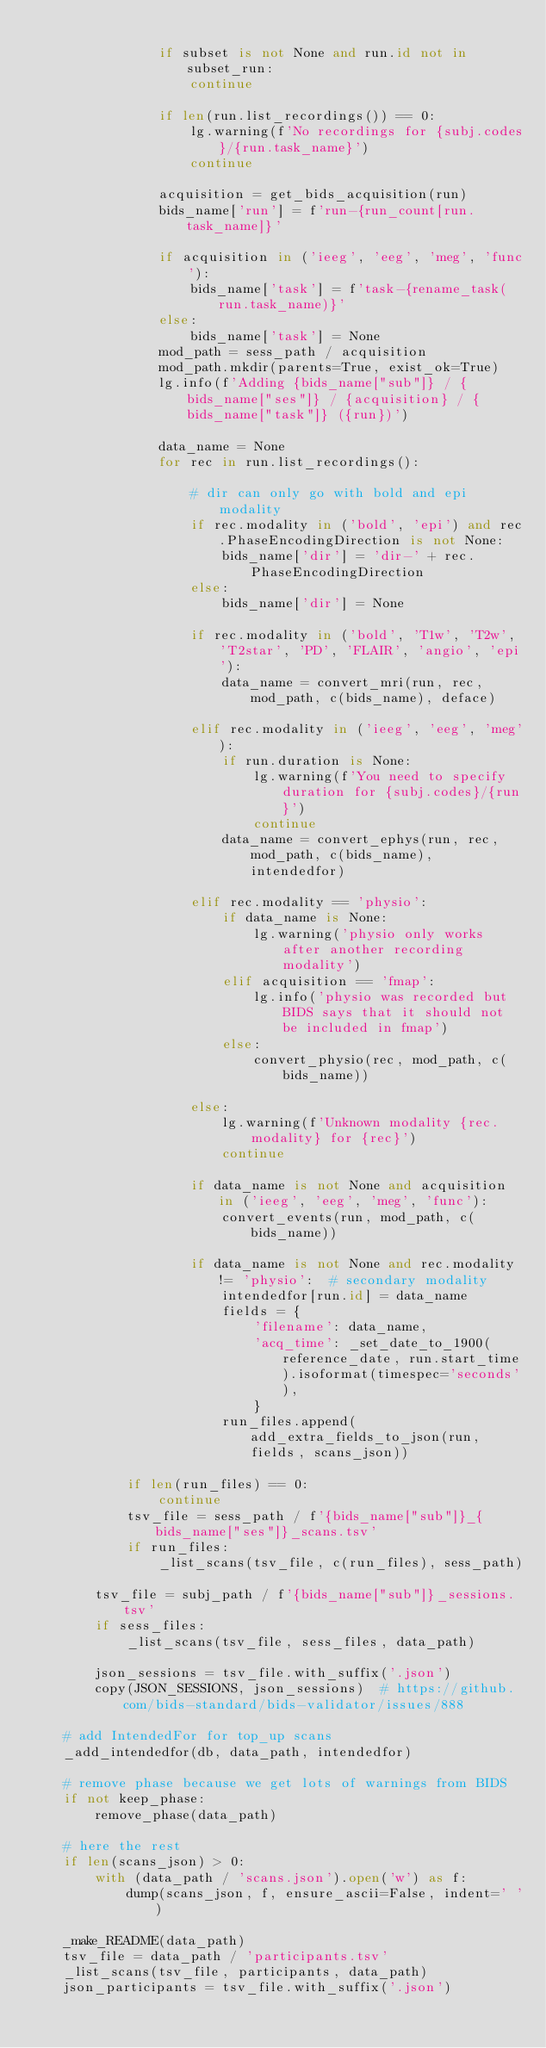Convert code to text. <code><loc_0><loc_0><loc_500><loc_500><_Python_>
                if subset is not None and run.id not in subset_run:
                    continue

                if len(run.list_recordings()) == 0:
                    lg.warning(f'No recordings for {subj.codes}/{run.task_name}')
                    continue

                acquisition = get_bids_acquisition(run)
                bids_name['run'] = f'run-{run_count[run.task_name]}'

                if acquisition in ('ieeg', 'eeg', 'meg', 'func'):
                    bids_name['task'] = f'task-{rename_task(run.task_name)}'
                else:
                    bids_name['task'] = None
                mod_path = sess_path / acquisition
                mod_path.mkdir(parents=True, exist_ok=True)
                lg.info(f'Adding {bids_name["sub"]} / {bids_name["ses"]} / {acquisition} / {bids_name["task"]} ({run})')

                data_name = None
                for rec in run.list_recordings():

                    # dir can only go with bold and epi modality
                    if rec.modality in ('bold', 'epi') and rec.PhaseEncodingDirection is not None:
                        bids_name['dir'] = 'dir-' + rec.PhaseEncodingDirection
                    else:
                        bids_name['dir'] = None

                    if rec.modality in ('bold', 'T1w', 'T2w', 'T2star', 'PD', 'FLAIR', 'angio', 'epi'):
                        data_name = convert_mri(run, rec, mod_path, c(bids_name), deface)

                    elif rec.modality in ('ieeg', 'eeg', 'meg'):
                        if run.duration is None:
                            lg.warning(f'You need to specify duration for {subj.codes}/{run}')
                            continue
                        data_name = convert_ephys(run, rec, mod_path, c(bids_name), intendedfor)

                    elif rec.modality == 'physio':
                        if data_name is None:
                            lg.warning('physio only works after another recording modality')
                        elif acquisition == 'fmap':
                            lg.info('physio was recorded but BIDS says that it should not be included in fmap')
                        else:
                            convert_physio(rec, mod_path, c(bids_name))

                    else:
                        lg.warning(f'Unknown modality {rec.modality} for {rec}')
                        continue

                    if data_name is not None and acquisition in ('ieeg', 'eeg', 'meg', 'func'):
                        convert_events(run, mod_path, c(bids_name))

                    if data_name is not None and rec.modality != 'physio':  # secondary modality
                        intendedfor[run.id] = data_name
                        fields = {
                            'filename': data_name,
                            'acq_time': _set_date_to_1900(reference_date, run.start_time).isoformat(timespec='seconds'),
                            }
                        run_files.append(add_extra_fields_to_json(run, fields, scans_json))

            if len(run_files) == 0:
                continue
            tsv_file = sess_path / f'{bids_name["sub"]}_{bids_name["ses"]}_scans.tsv'
            if run_files:
                _list_scans(tsv_file, c(run_files), sess_path)

        tsv_file = subj_path / f'{bids_name["sub"]}_sessions.tsv'
        if sess_files:
            _list_scans(tsv_file, sess_files, data_path)

        json_sessions = tsv_file.with_suffix('.json')
        copy(JSON_SESSIONS, json_sessions)  # https://github.com/bids-standard/bids-validator/issues/888

    # add IntendedFor for top_up scans
    _add_intendedfor(db, data_path, intendedfor)

    # remove phase because we get lots of warnings from BIDS
    if not keep_phase:
        remove_phase(data_path)

    # here the rest
    if len(scans_json) > 0:
        with (data_path / 'scans.json').open('w') as f:
            dump(scans_json, f, ensure_ascii=False, indent=' ')

    _make_README(data_path)
    tsv_file = data_path / 'participants.tsv'
    _list_scans(tsv_file, participants, data_path)
    json_participants = tsv_file.with_suffix('.json')</code> 